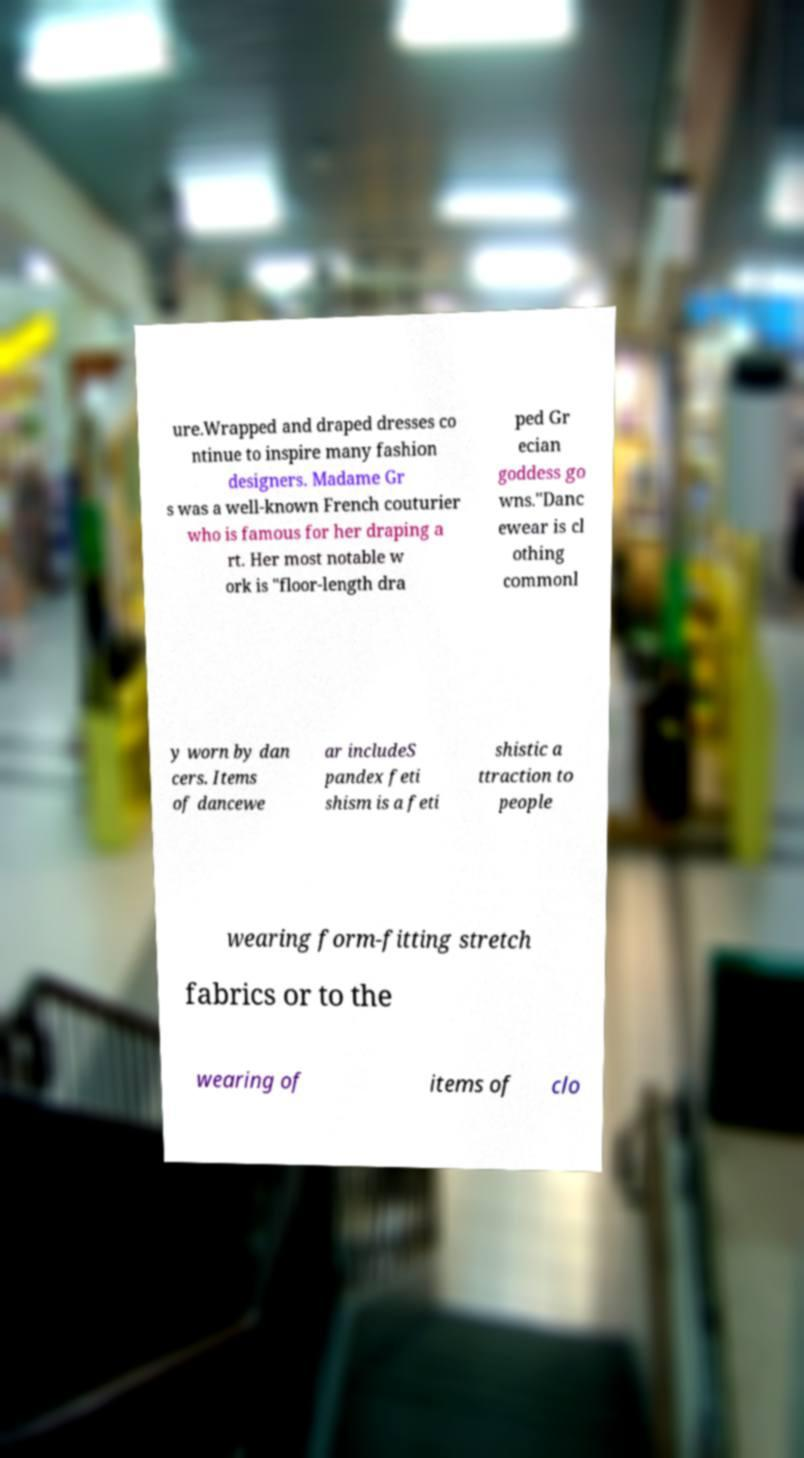What messages or text are displayed in this image? I need them in a readable, typed format. ure.Wrapped and draped dresses co ntinue to inspire many fashion designers. Madame Gr s was a well-known French couturier who is famous for her draping a rt. Her most notable w ork is "floor-length dra ped Gr ecian goddess go wns."Danc ewear is cl othing commonl y worn by dan cers. Items of dancewe ar includeS pandex feti shism is a feti shistic a ttraction to people wearing form-fitting stretch fabrics or to the wearing of items of clo 